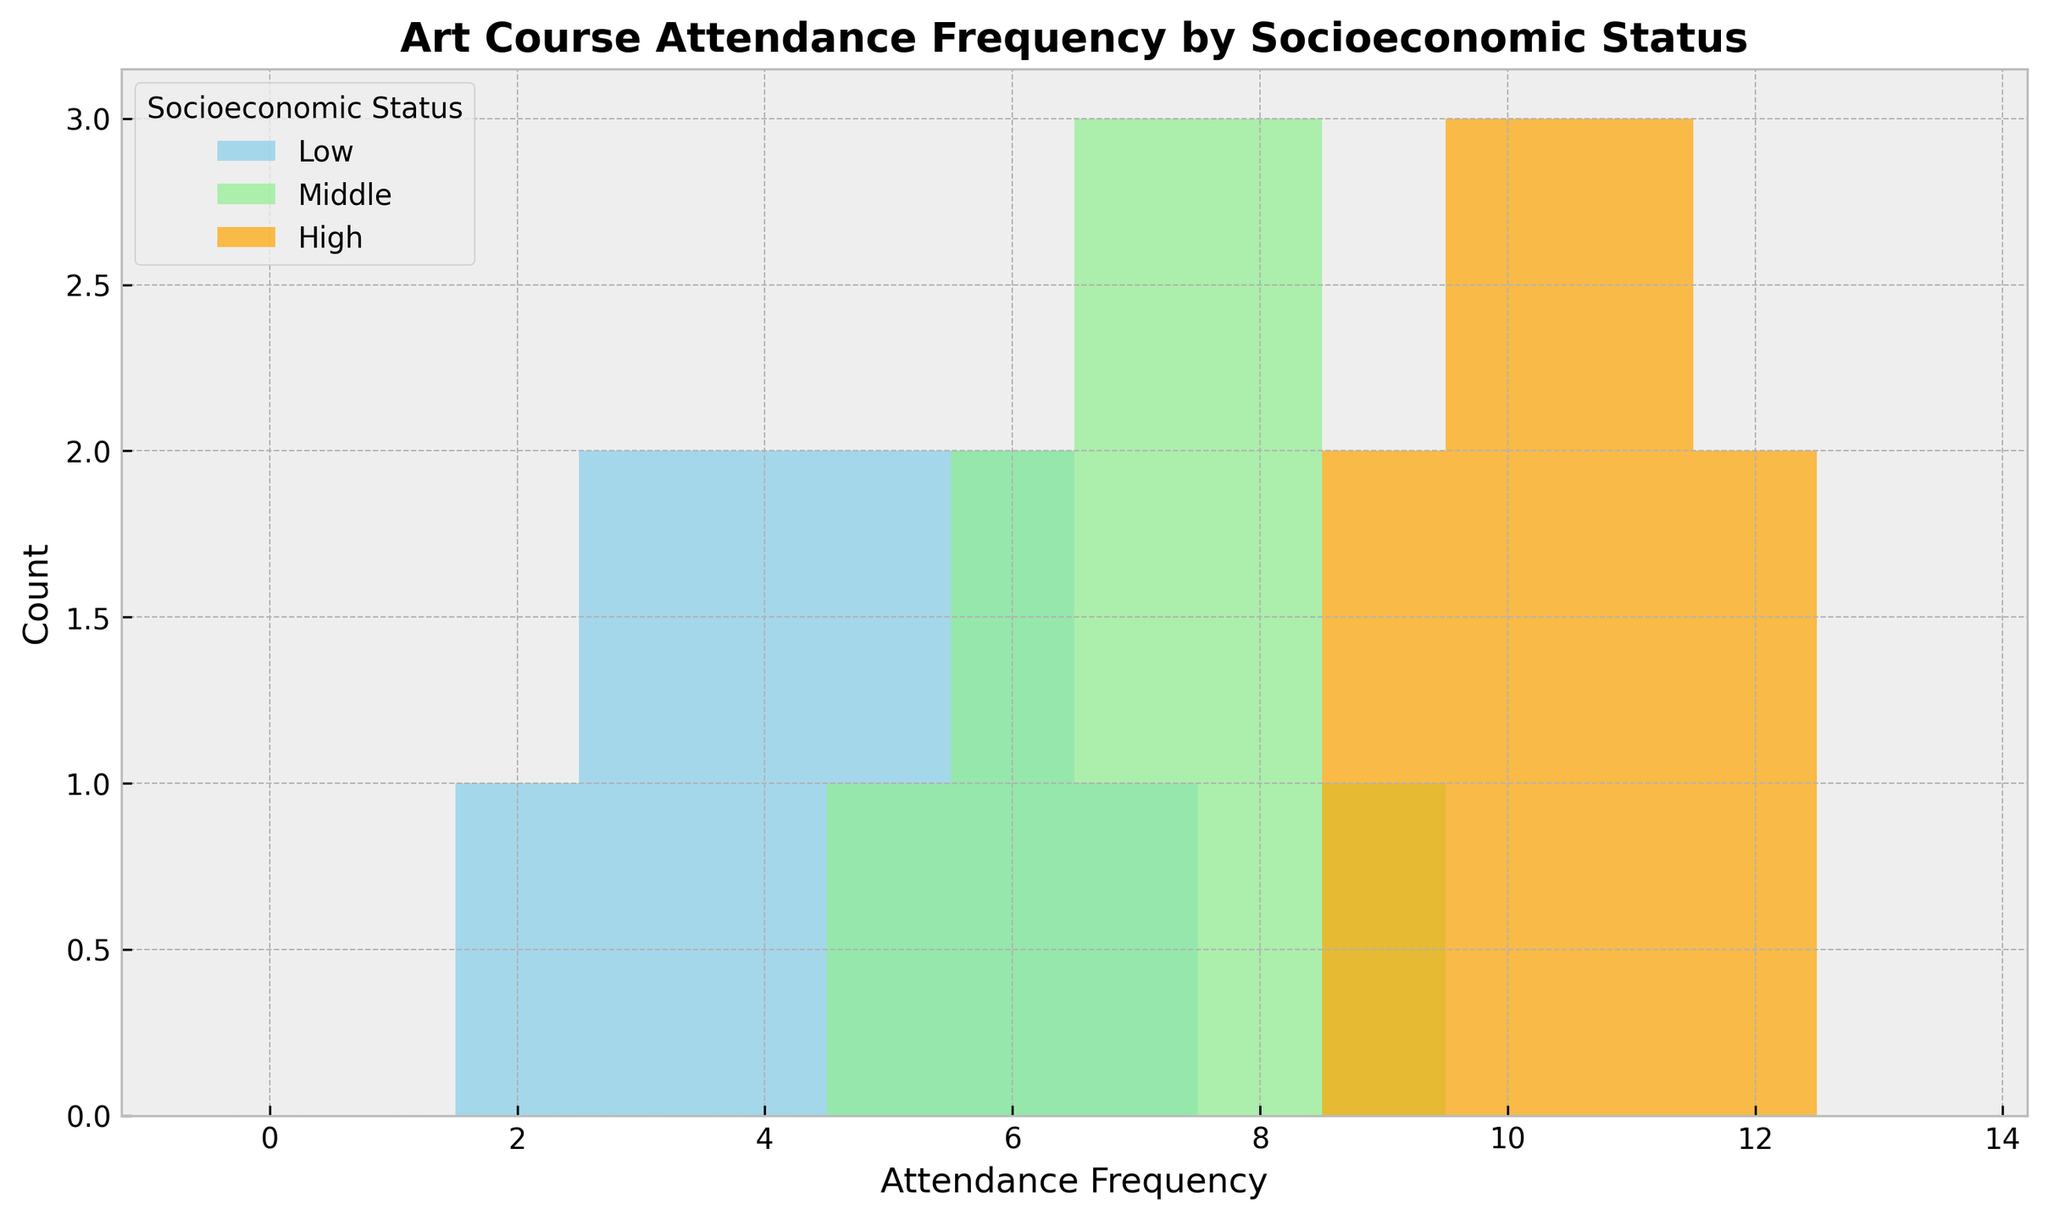Which socioeconomic status has the highest frequency for attending art courses? By observing the different colored histograms, we can quickly identify which group has the highest frequencies. The orange bars representing the High socioeconomic status have the highest frequencies for combinations like 10, 11, and 12.
Answer: High Which socioeconomic status group has the fewest instances of low attendance (frequency less than 5)? By looking at the histogram bars for frequencies less than 5, we can observe that the orange group (High socioeconomic status) has no bars, indicating zero instances of low attendance.
Answer: High What is the total number of attendance instances for Low socioeconomic status? We count all the histogram bars for the Low category. The counts are 1 (attendance = 2) + 2 (attendance = 3) + 2 (attendance = 4) + 2 (attendance = 5) + 2 (attendance = 6) + 1 (attendance = 7), which sums up to 10.
Answer: 10 Among the socioeconomic statuses, which has the most uniform distribution of attendance frequencies? By comparing the spread and height of the bars across the socioeconomic statuses, the Middle (light green) group has a more uniform distribution, with relatively similar heights for frequencies between 5 and 9.
Answer: Middle What is the average attendance frequency for the High socioeconomic status group? The total frequencies are (10 + 12 + 11 + 9 + 10 + 11 + 12 + 10 + 11 + 9) which equals 105. Dividing by the number of data points (10) gives 105 / 10, resulting in an average of 10.5.
Answer: 10.5 Which socioeconomic status has the highest peak count at a single attendance frequency? By observing the histograms, we see that the orange bars of the High socioeconomic status reach the tallest peak at frequency 11 with a count of 3.
Answer: High For the Middle socioeconomic status, what is the combined count for attendance frequencies 7 and 8? Counting the bars for the Middle group at frequencies 7 and 8, there are 3 bars at 7 and 4 bars at 8, totaling 3 + 4.
Answer: 7 How does the attendance frequency distribution of the Low socioeconomic status compare to the Middle socioeconomic status? The Low group (sky blue) is skewed towards lower attendance frequencies (2-7), while the Middle group (light green) is more concentrated around mid-range frequencies (5-9). The Low group also ends at a frequency of 7, whereas the Middle group continues till 9.
Answer: Low skewed lower, Middle more mid-range What is the range of attendance frequencies for the High socioeconomic status? Observing the orange bars for High socioeconomic status, the frequencies range from 9 to 12. The range is 12 - 9.
Answer: 3 